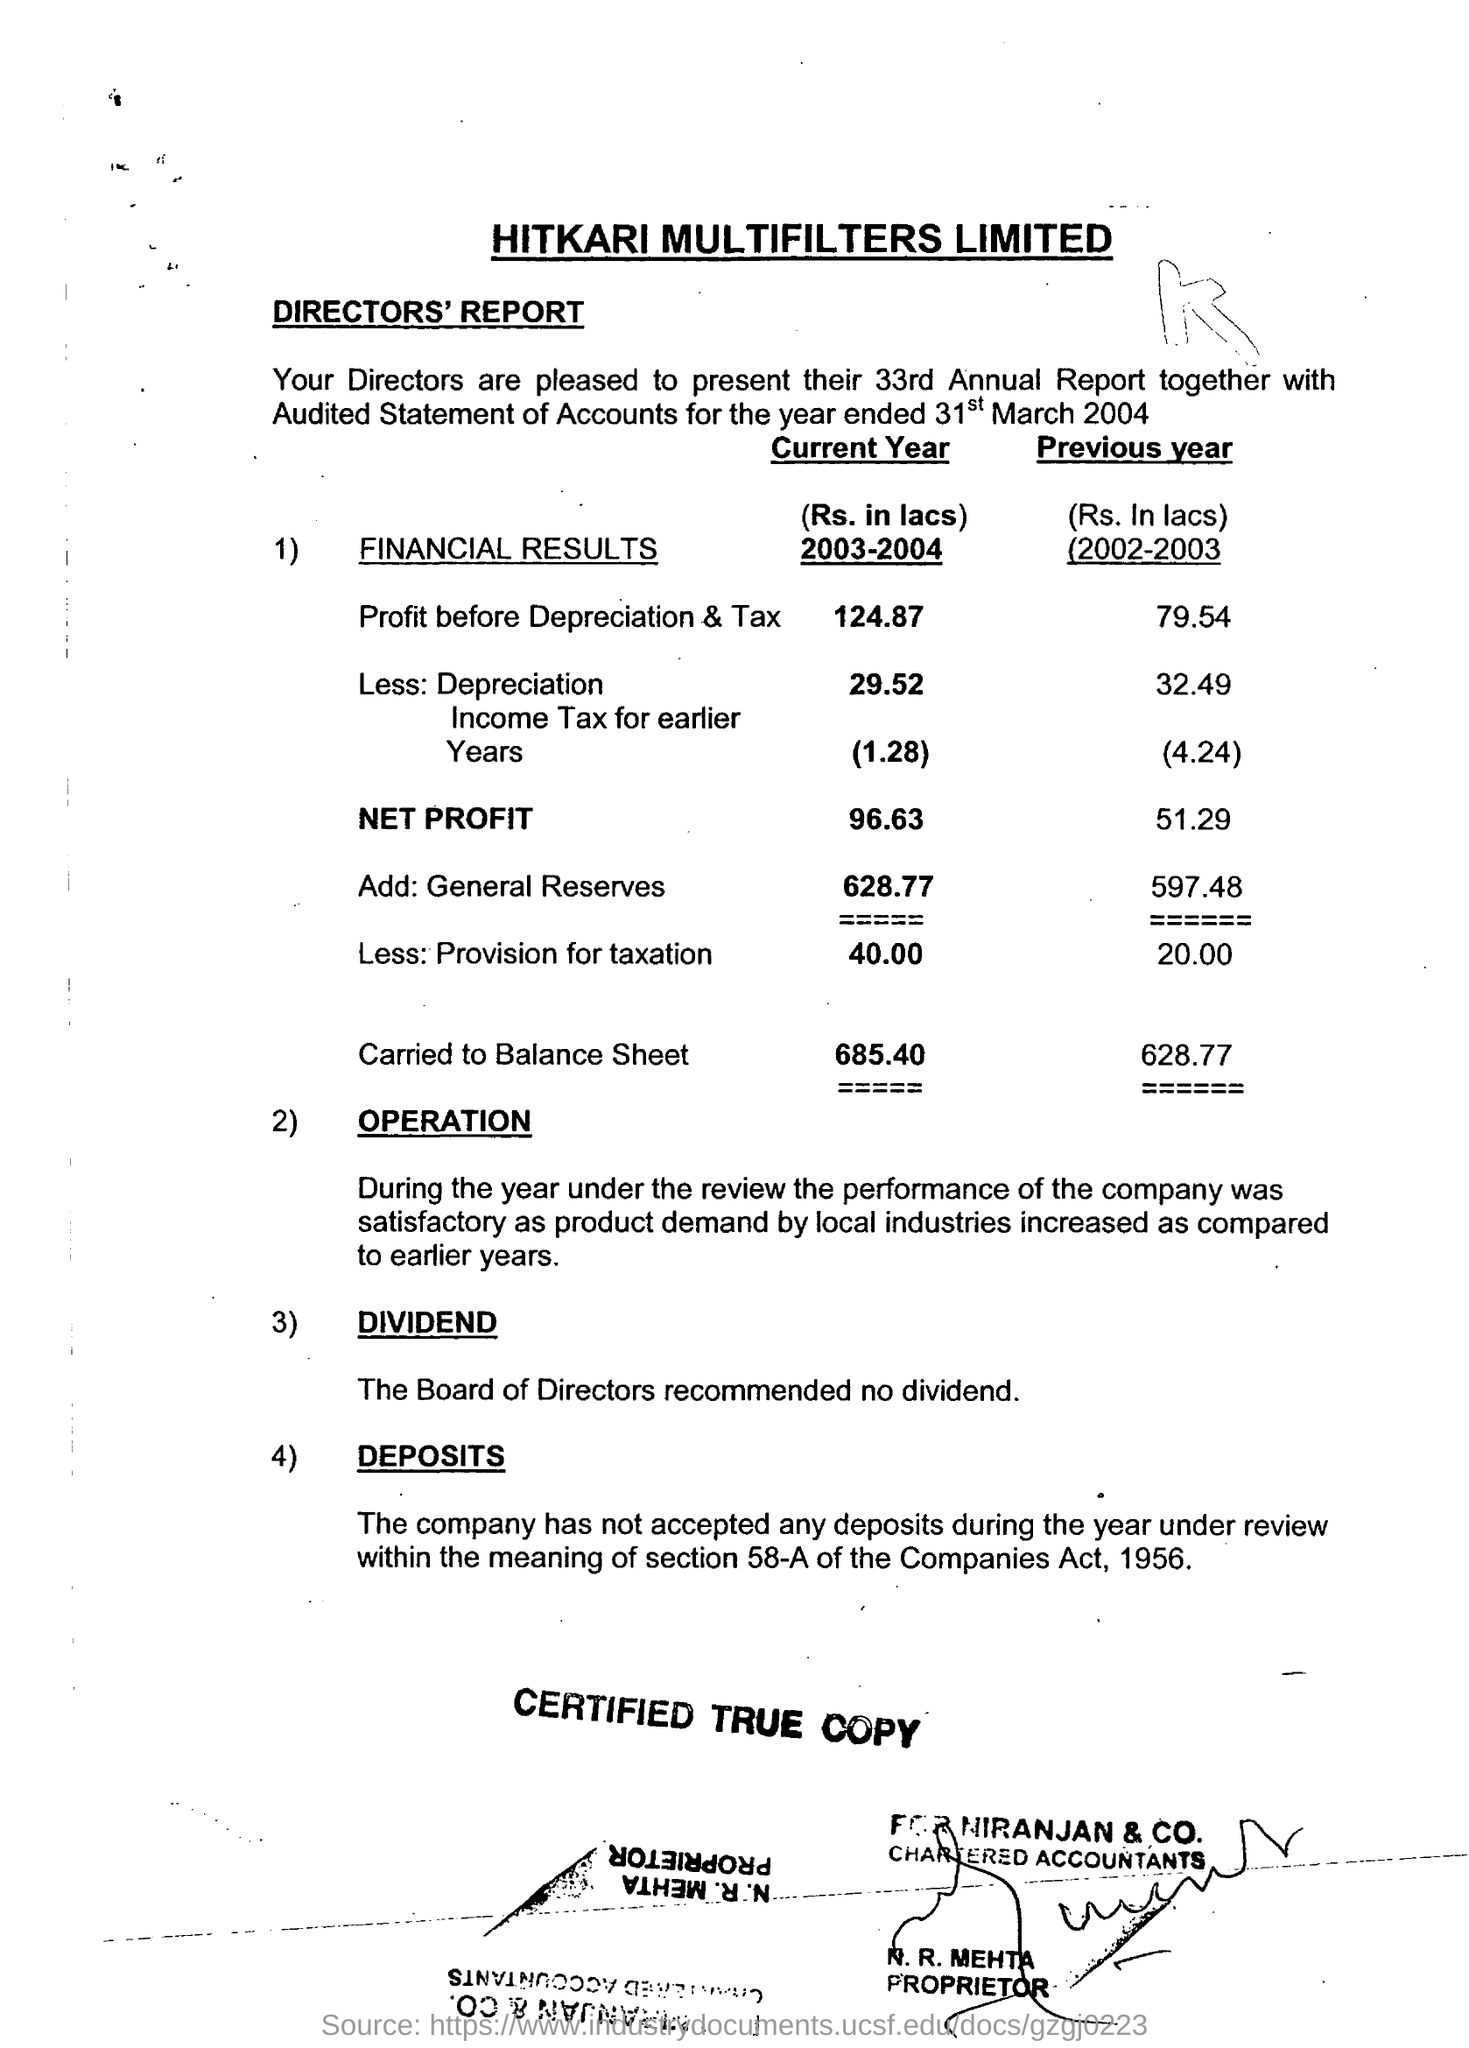What is the Title of the document ?
Give a very brief answer. HITKARI MULTIFILTERS LIMITED. How much amount Carried to balance sheet in 2003-2004 year ?
Keep it short and to the point. 685.40. What is the net profit  of Current Year?
Your answer should be very brief. 96.63. 